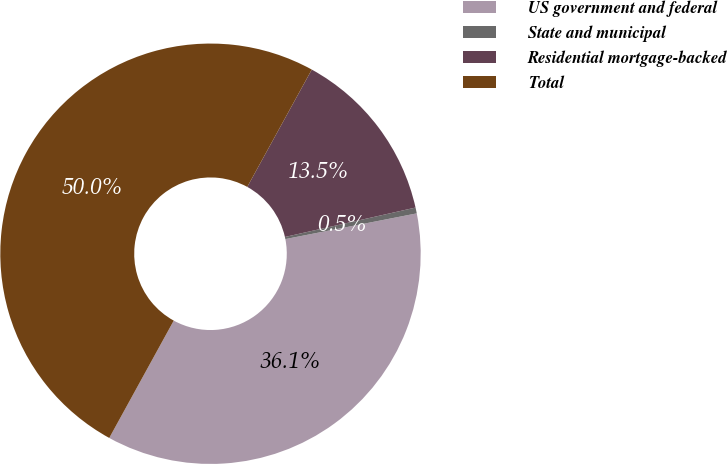Convert chart to OTSL. <chart><loc_0><loc_0><loc_500><loc_500><pie_chart><fcel>US government and federal<fcel>State and municipal<fcel>Residential mortgage-backed<fcel>Total<nl><fcel>36.07%<fcel>0.45%<fcel>13.47%<fcel>50.0%<nl></chart> 